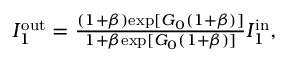<formula> <loc_0><loc_0><loc_500><loc_500>\begin{array} { r } { I _ { 1 } ^ { o u t } = \frac { ( 1 + \beta ) e x p [ G _ { 0 } ( 1 + \beta ) ] } { 1 + \beta e x p [ G _ { 0 } ( 1 + \beta ) ] } I _ { 1 } ^ { i n } , } \end{array}</formula> 